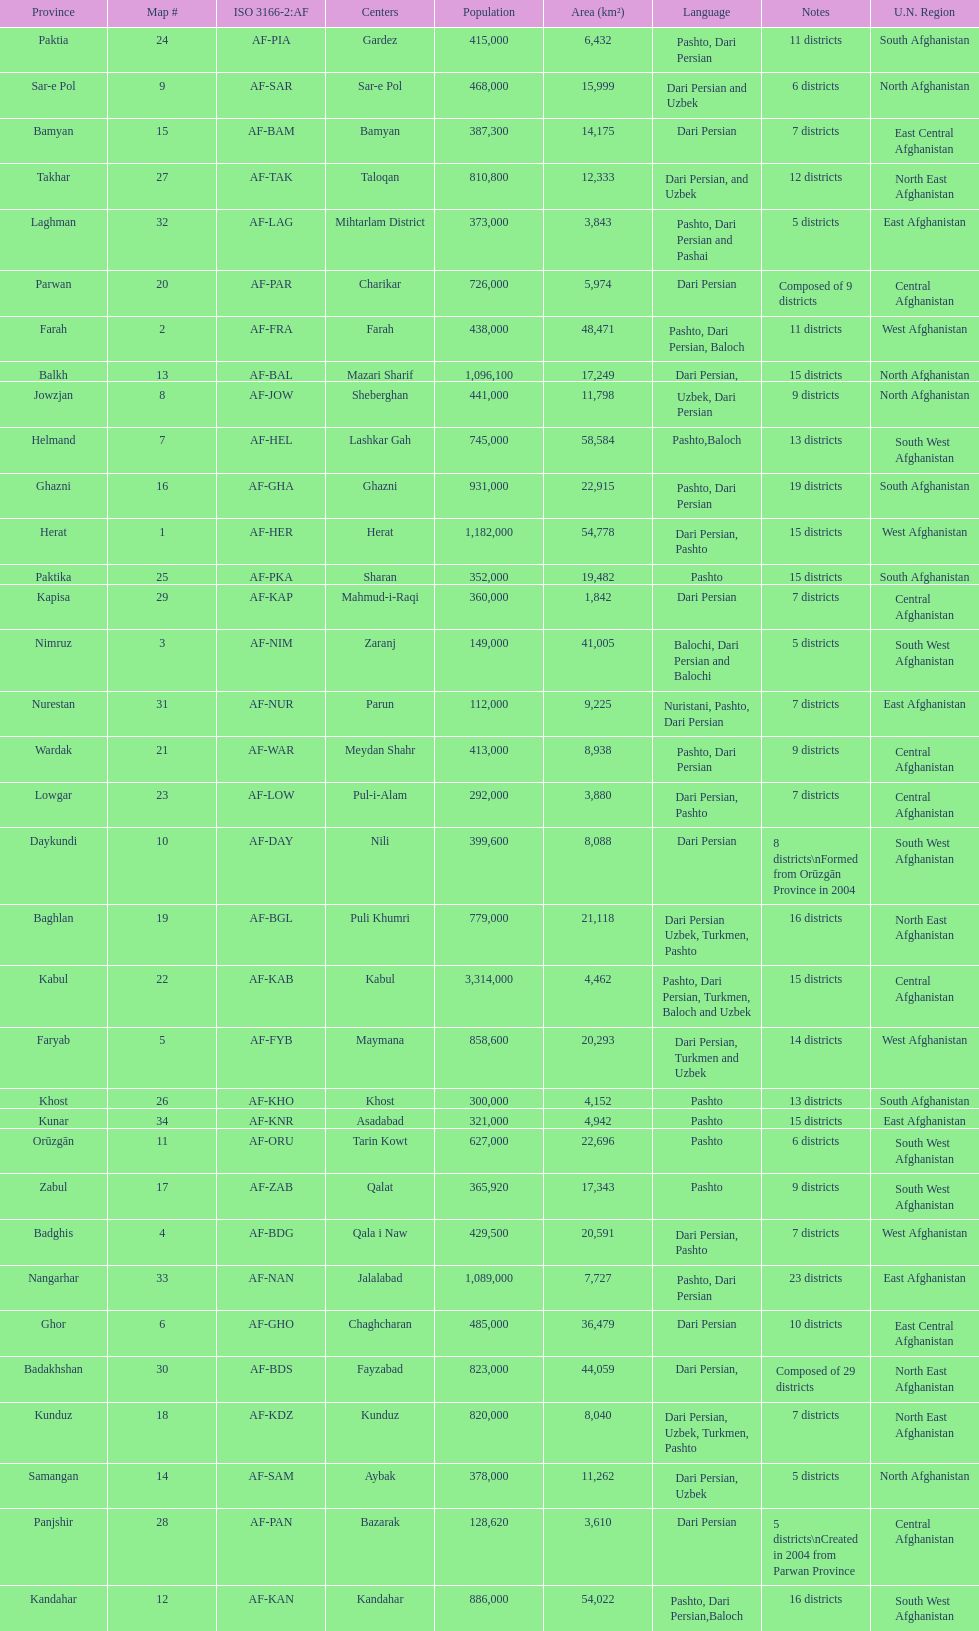Write the full table. {'header': ['Province', 'Map #', 'ISO 3166-2:AF', 'Centers', 'Population', 'Area (km²)', 'Language', 'Notes', 'U.N. Region'], 'rows': [['Paktia', '24', 'AF-PIA', 'Gardez', '415,000', '6,432', 'Pashto, Dari Persian', '11 districts', 'South Afghanistan'], ['Sar-e Pol', '9', 'AF-SAR', 'Sar-e Pol', '468,000', '15,999', 'Dari Persian and Uzbek', '6 districts', 'North Afghanistan'], ['Bamyan', '15', 'AF-BAM', 'Bamyan', '387,300', '14,175', 'Dari Persian', '7 districts', 'East Central Afghanistan'], ['Takhar', '27', 'AF-TAK', 'Taloqan', '810,800', '12,333', 'Dari Persian, and Uzbek', '12 districts', 'North East Afghanistan'], ['Laghman', '32', 'AF-LAG', 'Mihtarlam District', '373,000', '3,843', 'Pashto, Dari Persian and Pashai', '5 districts', 'East Afghanistan'], ['Parwan', '20', 'AF-PAR', 'Charikar', '726,000', '5,974', 'Dari Persian', 'Composed of 9 districts', 'Central Afghanistan'], ['Farah', '2', 'AF-FRA', 'Farah', '438,000', '48,471', 'Pashto, Dari Persian, Baloch', '11 districts', 'West Afghanistan'], ['Balkh', '13', 'AF-BAL', 'Mazari Sharif', '1,096,100', '17,249', 'Dari Persian,', '15 districts', 'North Afghanistan'], ['Jowzjan', '8', 'AF-JOW', 'Sheberghan', '441,000', '11,798', 'Uzbek, Dari Persian', '9 districts', 'North Afghanistan'], ['Helmand', '7', 'AF-HEL', 'Lashkar Gah', '745,000', '58,584', 'Pashto,Baloch', '13 districts', 'South West Afghanistan'], ['Ghazni', '16', 'AF-GHA', 'Ghazni', '931,000', '22,915', 'Pashto, Dari Persian', '19 districts', 'South Afghanistan'], ['Herat', '1', 'AF-HER', 'Herat', '1,182,000', '54,778', 'Dari Persian, Pashto', '15 districts', 'West Afghanistan'], ['Paktika', '25', 'AF-PKA', 'Sharan', '352,000', '19,482', 'Pashto', '15 districts', 'South Afghanistan'], ['Kapisa', '29', 'AF-KAP', 'Mahmud-i-Raqi', '360,000', '1,842', 'Dari Persian', '7 districts', 'Central Afghanistan'], ['Nimruz', '3', 'AF-NIM', 'Zaranj', '149,000', '41,005', 'Balochi, Dari Persian and Balochi', '5 districts', 'South West Afghanistan'], ['Nurestan', '31', 'AF-NUR', 'Parun', '112,000', '9,225', 'Nuristani, Pashto, Dari Persian', '7 districts', 'East Afghanistan'], ['Wardak', '21', 'AF-WAR', 'Meydan Shahr', '413,000', '8,938', 'Pashto, Dari Persian', '9 districts', 'Central Afghanistan'], ['Lowgar', '23', 'AF-LOW', 'Pul-i-Alam', '292,000', '3,880', 'Dari Persian, Pashto', '7 districts', 'Central Afghanistan'], ['Daykundi', '10', 'AF-DAY', 'Nili', '399,600', '8,088', 'Dari Persian', '8 districts\\nFormed from Orūzgān Province in 2004', 'South West Afghanistan'], ['Baghlan', '19', 'AF-BGL', 'Puli Khumri', '779,000', '21,118', 'Dari Persian Uzbek, Turkmen, Pashto', '16 districts', 'North East Afghanistan'], ['Kabul', '22', 'AF-KAB', 'Kabul', '3,314,000', '4,462', 'Pashto, Dari Persian, Turkmen, Baloch and Uzbek', '15 districts', 'Central Afghanistan'], ['Faryab', '5', 'AF-FYB', 'Maymana', '858,600', '20,293', 'Dari Persian, Turkmen and Uzbek', '14 districts', 'West Afghanistan'], ['Khost', '26', 'AF-KHO', 'Khost', '300,000', '4,152', 'Pashto', '13 districts', 'South Afghanistan'], ['Kunar', '34', 'AF-KNR', 'Asadabad', '321,000', '4,942', 'Pashto', '15 districts', 'East Afghanistan'], ['Orūzgān', '11', 'AF-ORU', 'Tarin Kowt', '627,000', '22,696', 'Pashto', '6 districts', 'South West Afghanistan'], ['Zabul', '17', 'AF-ZAB', 'Qalat', '365,920', '17,343', 'Pashto', '9 districts', 'South West Afghanistan'], ['Badghis', '4', 'AF-BDG', 'Qala i Naw', '429,500', '20,591', 'Dari Persian, Pashto', '7 districts', 'West Afghanistan'], ['Nangarhar', '33', 'AF-NAN', 'Jalalabad', '1,089,000', '7,727', 'Pashto, Dari Persian', '23 districts', 'East Afghanistan'], ['Ghor', '6', 'AF-GHO', 'Chaghcharan', '485,000', '36,479', 'Dari Persian', '10 districts', 'East Central Afghanistan'], ['Badakhshan', '30', 'AF-BDS', 'Fayzabad', '823,000', '44,059', 'Dari Persian,', 'Composed of 29 districts', 'North East Afghanistan'], ['Kunduz', '18', 'AF-KDZ', 'Kunduz', '820,000', '8,040', 'Dari Persian, Uzbek, Turkmen, Pashto', '7 districts', 'North East Afghanistan'], ['Samangan', '14', 'AF-SAM', 'Aybak', '378,000', '11,262', 'Dari Persian, Uzbek', '5 districts', 'North Afghanistan'], ['Panjshir', '28', 'AF-PAN', 'Bazarak', '128,620', '3,610', 'Dari Persian', '5 districts\\nCreated in 2004 from Parwan Province', 'Central Afghanistan'], ['Kandahar', '12', 'AF-KAN', 'Kandahar', '886,000', '54,022', 'Pashto, Dari Persian,Baloch', '16 districts', 'South West Afghanistan']]} Does ghor or farah have more districts? Farah. 